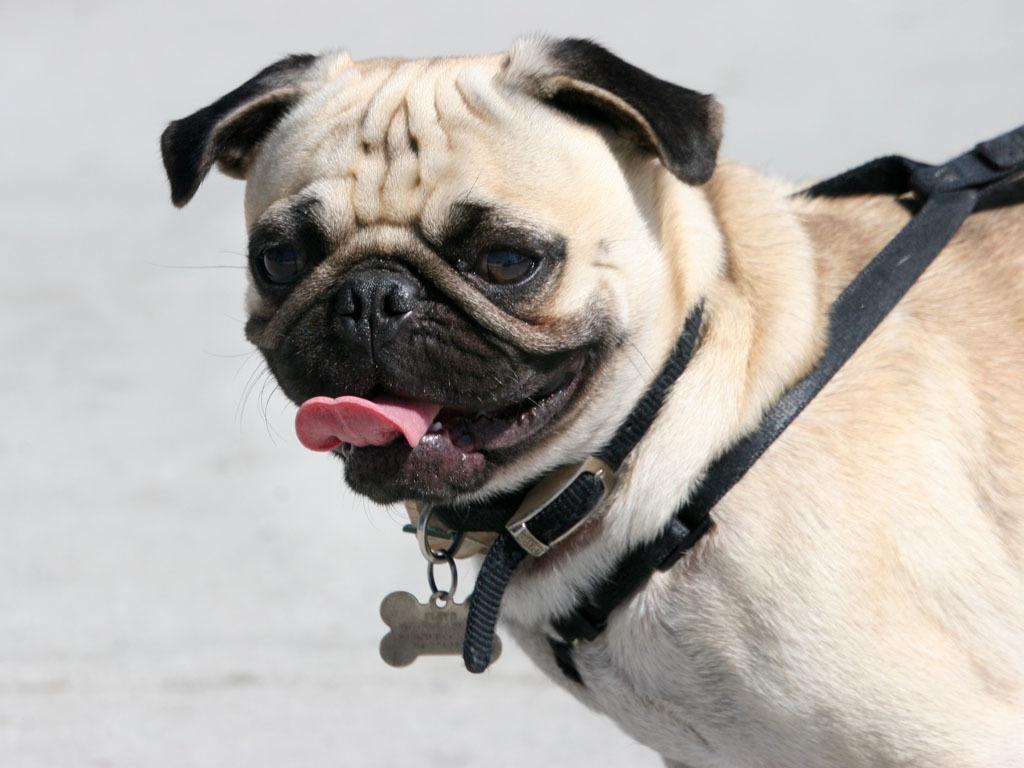Describe this image in one or two sentences. In this image we can see a dog and a white background. 